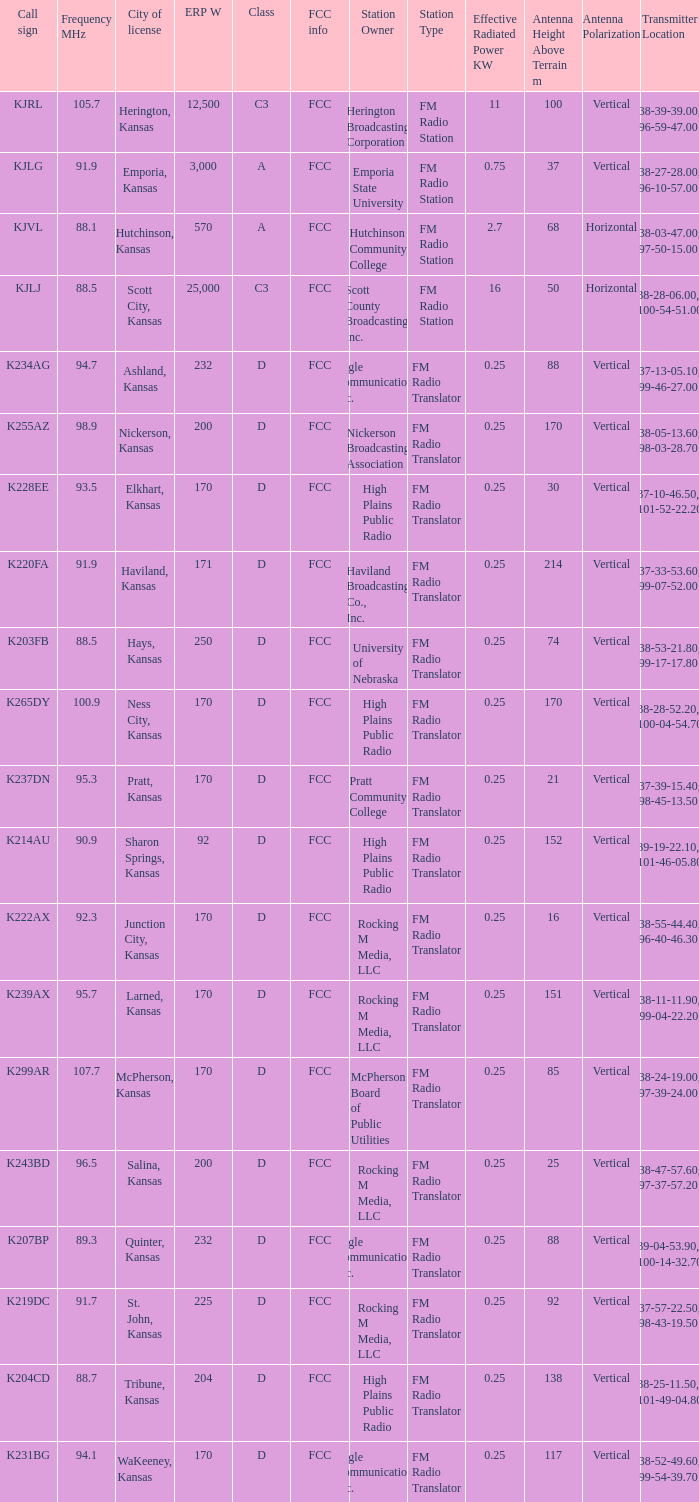Call sign of k231bg has what sum of erp w? 170.0. 